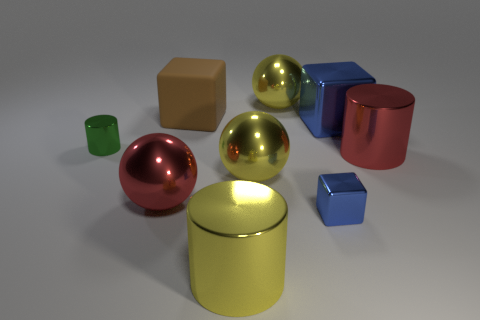Subtract all blue blocks. How many were subtracted if there are1blue blocks left? 1 Add 1 small purple metallic things. How many objects exist? 10 Subtract all cylinders. How many objects are left? 6 Subtract all small cylinders. Subtract all small metal cubes. How many objects are left? 7 Add 1 blocks. How many blocks are left? 4 Add 6 red things. How many red things exist? 8 Subtract 0 yellow blocks. How many objects are left? 9 